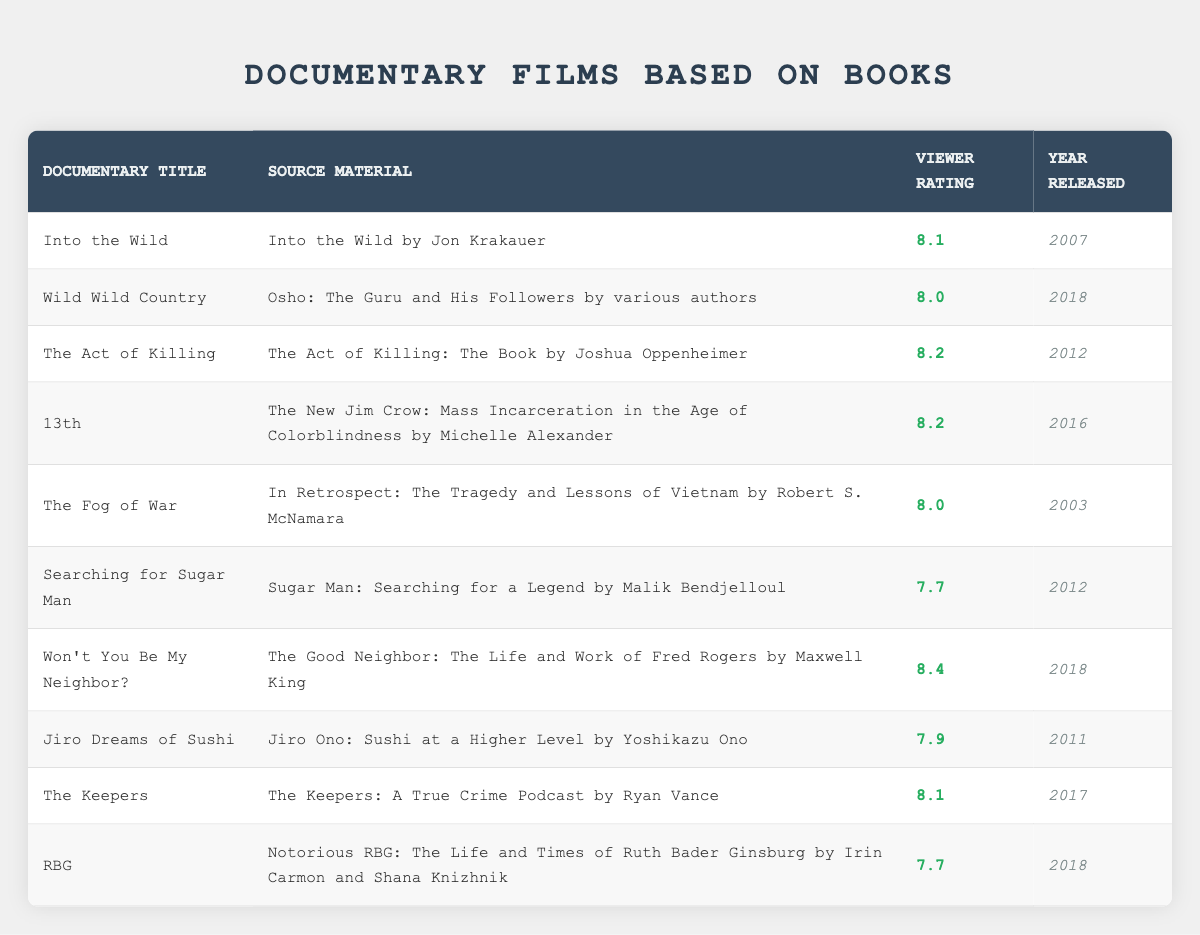What is the viewer rating of "Wild Wild Country"? The documentary "Wild Wild Country" has a viewer rating listed in the table as 8.0.
Answer: 8.0 Which documentary has the highest viewer rating? To find the highest viewer rating in the table, compare the viewer ratings: 8.1 (Into the Wild), 8.0 (Wild Wild Country), 8.2 (The Act of Killing), 8.2 (13th), 8.0 (The Fog of War), 7.7 (Searching for Sugar Man), 8.4 (Won't You Be My Neighbor?), 7.9 (Jiro Dreams of Sushi), 8.1 (The Keepers), and 7.7 (RBG). The highest rating is 8.4 for "Won't You Be My Neighbor?".
Answer: Won't You Be My Neighbor? How many documentaries have a viewer rating of 8.0 or higher? Count the documentaries with ratings of 8.0 or more: "Into the Wild" (8.1), "Wild Wild Country" (8.0), "The Act of Killing" (8.2), "13th" (8.2), "The Fog of War" (8.0), "Won't You Be My Neighbor?" (8.4), and "The Keepers" (8.1) for a total of 7 documentaries.
Answer: 7 Is "RBG" the only documentary with a viewer rating below 8.0? Check the ratings for "RBG" (7.7) and compare with others: "Searching for Sugar Man" (7.7) also has a rating below 8.0. Therefore, "RBG" is not the only one with a rating below 8.0.
Answer: No What is the average viewer rating of documentaries released after 2015? Collect the ratings from documentaries released after 2015: "Wild Wild Country" (2018, 8.0), "13th" (2016, 8.2), "Won't You Be My Neighbor?" (2018, 8.4), and "RBG" (2018, 7.7). Calculate the average: (8.0 + 8.2 + 8.4 + 7.7) = 32.3, with 4 documentaries, so the average is 32.3 / 4 = 8.075.
Answer: 8.075 